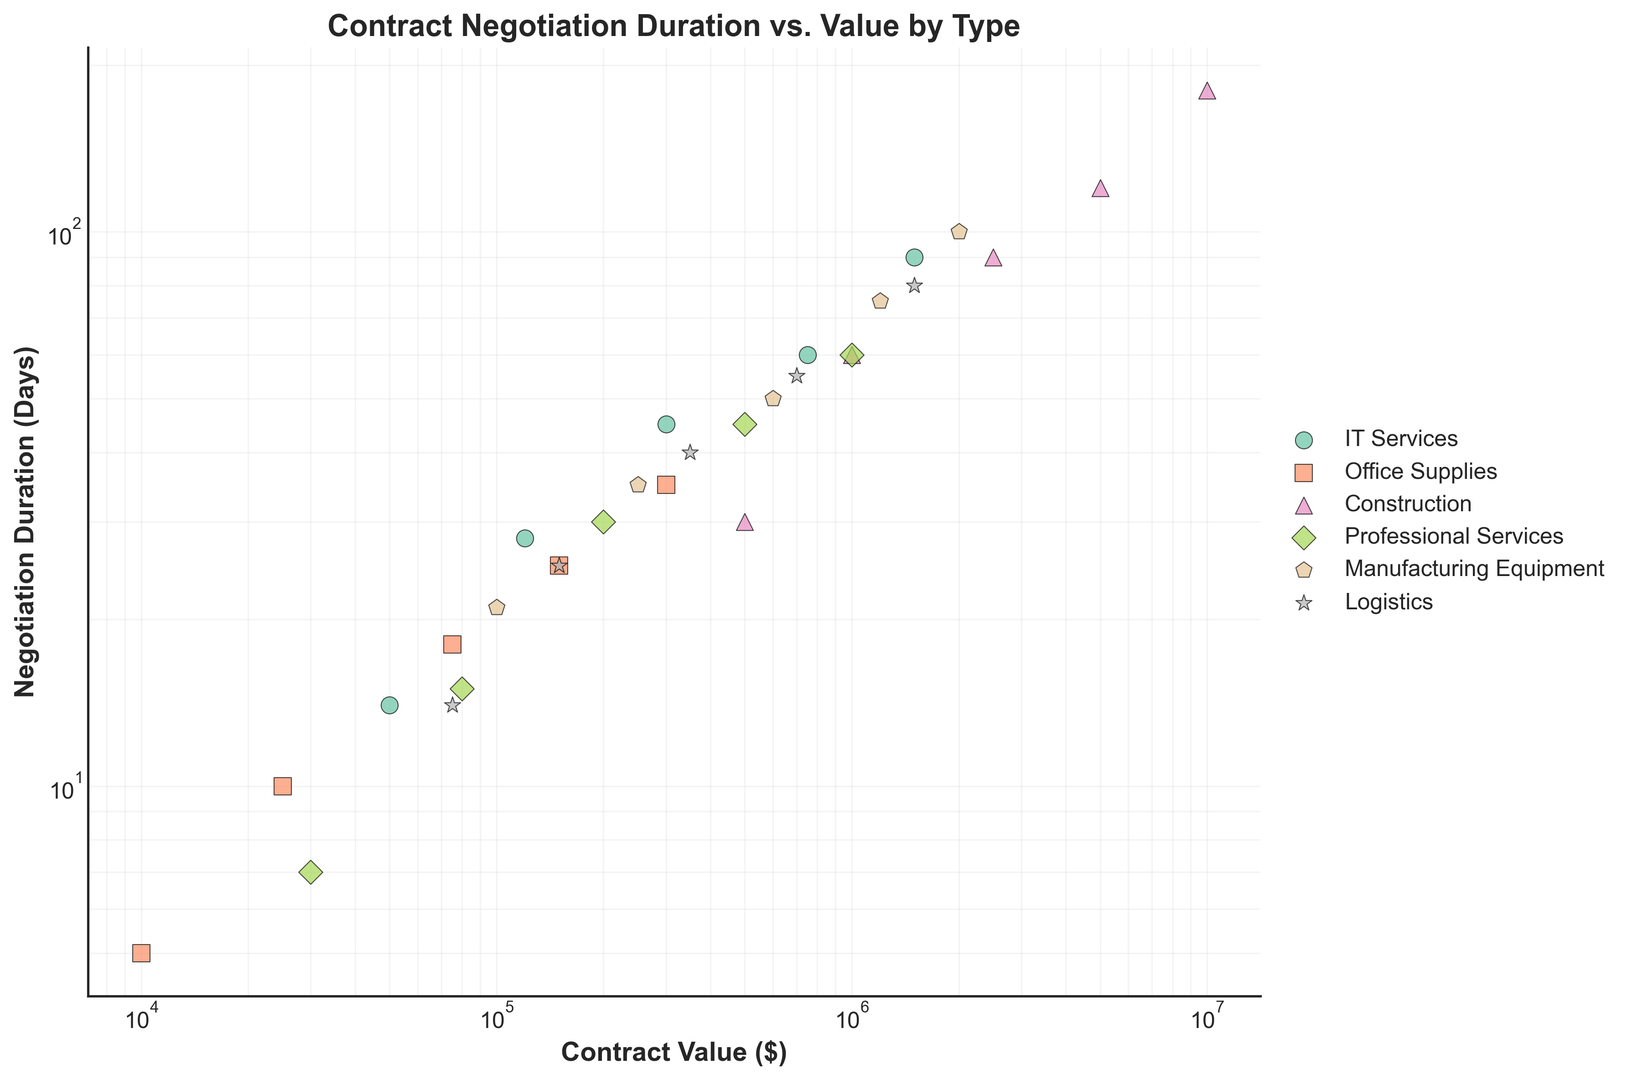What is the contract type with the largest average negotiation duration? To find this, first calculate the average negotiation duration for each contract type by summing the negotiation durations and dividing by the number of contracts for each type. The contract type with the highest average is the one with the largest value.
Answer: Construction Which contract type has the shortest negotiation duration for a $150,000 contract value? Locate the data points for each contract type with a $150,000 value and compare the corresponding negotiation durations. The contract type with the smallest number of days is the answer.
Answer: Office Supplies Compare the negotiation duration for a $1,000,000 value contract between IT Services and Construction. Which one is shorter? Identify the data points for both IT Services and Construction with a $1,000,000 value. Compare their associated negotiation durations and determine which one is smaller.
Answer: IT Services Between which contract values does the largest increase in negotiation duration occur for Manufacturing Equipment? Assess the negotiation durations of each contract value for Manufacturing Equipment and calculate the differences between consecutive values. Identify the pair of values with the largest increase.
Answer: $1,200,000 to $2,000,000 What is the median negotiation duration for Office Supplies contracts? List the negotiation durations for Office Supplies contracts, sort them, and determine the middle value. For 5 durations (5, 10, 18, 25, 35), the median is the third value.
Answer: 18 Which contract type has the widest range of negotiation durations? Calculate the range (difference between maximum and minimum values) of negotiation durations for each contract type. Identify the one with the largest range.
Answer: Construction Are there more contract types with an initial negotiation duration of 30 days or 60 days? Count the number of contract types that have a data point starting at 30 days and those starting at 60 days. Compare the counts.
Answer: Equal How does the negotiation duration for Logistics compare to Manufacturing Equipment for contracts around $1,500,000? Locate the data points around $1,500,000 for both Logistics and Manufacturing Equipment, and compare their negotiation durations.
Answer: Logistics is shorter Which contract type has the most consistent negotiation duration relative to contract value? Evaluate the variation in negotiation durations for each contract type relative to their contract values. The type with the least variation is the most consistent.
Answer: Office Supplies What is the difference in negotiation duration between the highest and lowest contract values of Professional Services? Identify the negotiation durations for the highest and lowest contract values of Professional Services ($1,000,000 and $30,000), then calculate the difference.
Answer: 53 days 